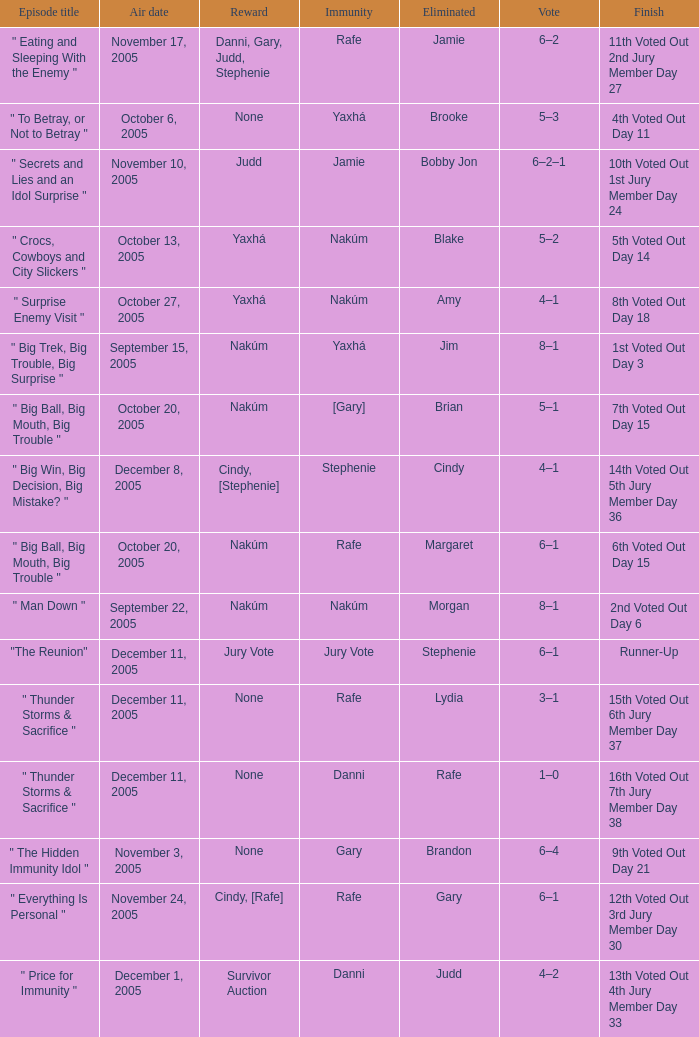Parse the full table. {'header': ['Episode title', 'Air date', 'Reward', 'Immunity', 'Eliminated', 'Vote', 'Finish'], 'rows': [['" Eating and Sleeping With the Enemy "', 'November 17, 2005', 'Danni, Gary, Judd, Stephenie', 'Rafe', 'Jamie', '6–2', '11th Voted Out 2nd Jury Member Day 27'], ['" To Betray, or Not to Betray "', 'October 6, 2005', 'None', 'Yaxhá', 'Brooke', '5–3', '4th Voted Out Day 11'], ['" Secrets and Lies and an Idol Surprise "', 'November 10, 2005', 'Judd', 'Jamie', 'Bobby Jon', '6–2–1', '10th Voted Out 1st Jury Member Day 24'], ['" Crocs, Cowboys and City Slickers "', 'October 13, 2005', 'Yaxhá', 'Nakúm', 'Blake', '5–2', '5th Voted Out Day 14'], ['" Surprise Enemy Visit "', 'October 27, 2005', 'Yaxhá', 'Nakúm', 'Amy', '4–1', '8th Voted Out Day 18'], ['" Big Trek, Big Trouble, Big Surprise "', 'September 15, 2005', 'Nakúm', 'Yaxhá', 'Jim', '8–1', '1st Voted Out Day 3'], ['" Big Ball, Big Mouth, Big Trouble "', 'October 20, 2005', 'Nakúm', '[Gary]', 'Brian', '5–1', '7th Voted Out Day 15'], ['" Big Win, Big Decision, Big Mistake? "', 'December 8, 2005', 'Cindy, [Stephenie]', 'Stephenie', 'Cindy', '4–1', '14th Voted Out 5th Jury Member Day 36'], ['" Big Ball, Big Mouth, Big Trouble "', 'October 20, 2005', 'Nakúm', 'Rafe', 'Margaret', '6–1', '6th Voted Out Day 15'], ['" Man Down "', 'September 22, 2005', 'Nakúm', 'Nakúm', 'Morgan', '8–1', '2nd Voted Out Day 6'], ['"The Reunion"', 'December 11, 2005', 'Jury Vote', 'Jury Vote', 'Stephenie', '6–1', 'Runner-Up'], ['" Thunder Storms & Sacrifice "', 'December 11, 2005', 'None', 'Rafe', 'Lydia', '3–1', '15th Voted Out 6th Jury Member Day 37'], ['" Thunder Storms & Sacrifice "', 'December 11, 2005', 'None', 'Danni', 'Rafe', '1–0', '16th Voted Out 7th Jury Member Day 38'], ['" The Hidden Immunity Idol "', 'November 3, 2005', 'None', 'Gary', 'Brandon', '6–4', '9th Voted Out Day 21'], ['" Everything Is Personal "', 'November 24, 2005', 'Cindy, [Rafe]', 'Rafe', 'Gary', '6–1', '12th Voted Out 3rd Jury Member Day 30'], ['" Price for Immunity "', 'December 1, 2005', 'Survivor Auction', 'Danni', 'Judd', '4–2', '13th Voted Out 4th Jury Member Day 33']]} How many rewards are there for air date October 6, 2005? None. 